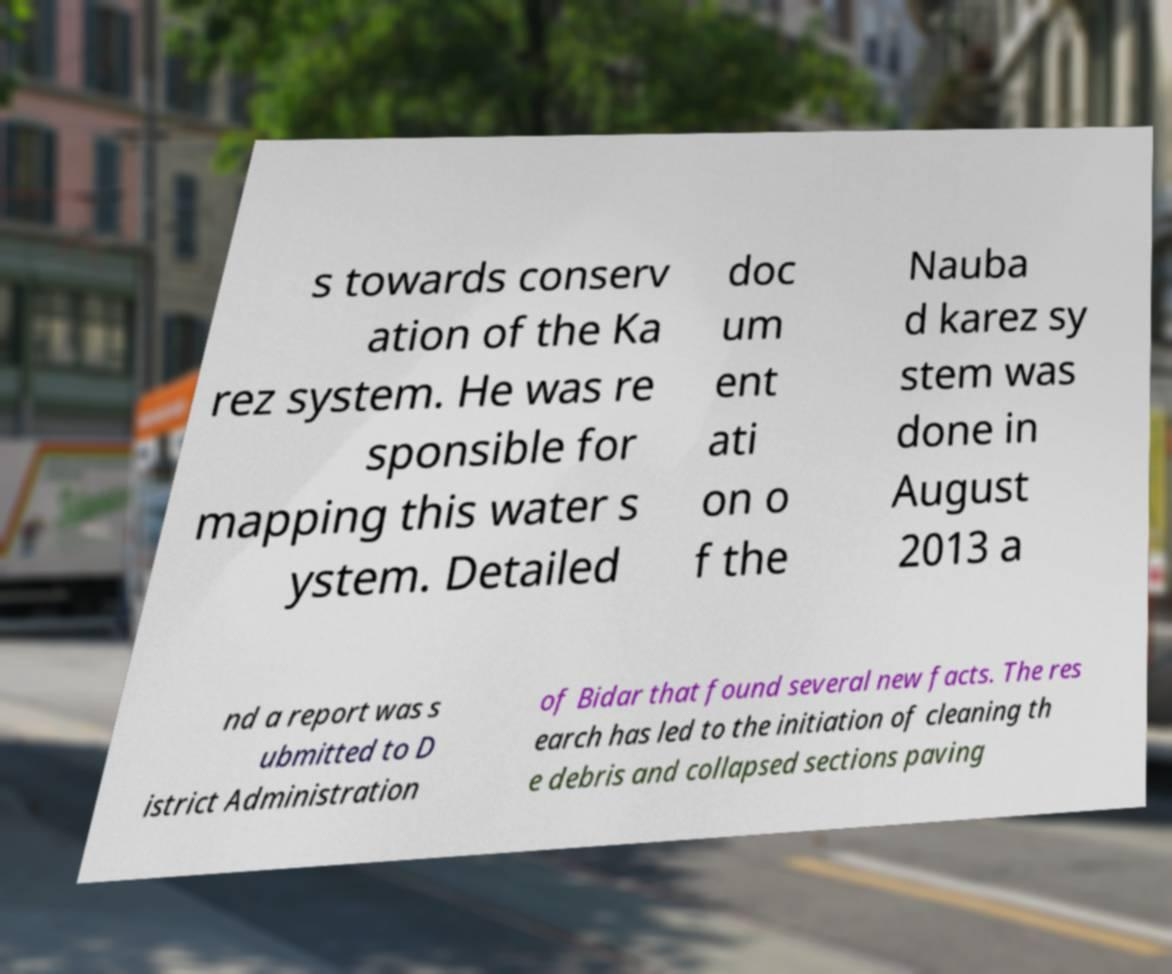There's text embedded in this image that I need extracted. Can you transcribe it verbatim? s towards conserv ation of the Ka rez system. He was re sponsible for mapping this water s ystem. Detailed doc um ent ati on o f the Nauba d karez sy stem was done in August 2013 a nd a report was s ubmitted to D istrict Administration of Bidar that found several new facts. The res earch has led to the initiation of cleaning th e debris and collapsed sections paving 